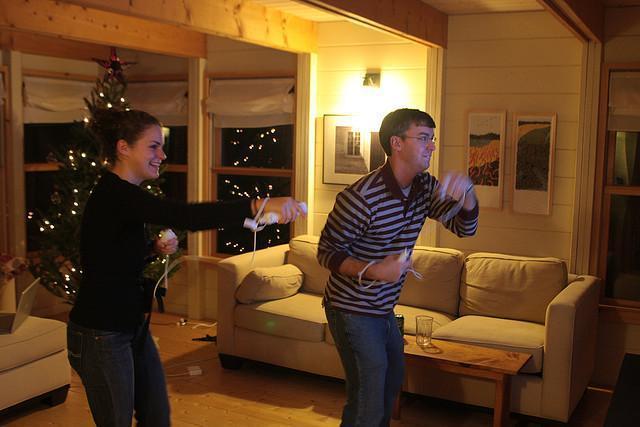How many pictures are on the wall?
Give a very brief answer. 3. How many people can be seen?
Give a very brief answer. 2. How many couches are in the picture?
Give a very brief answer. 2. 